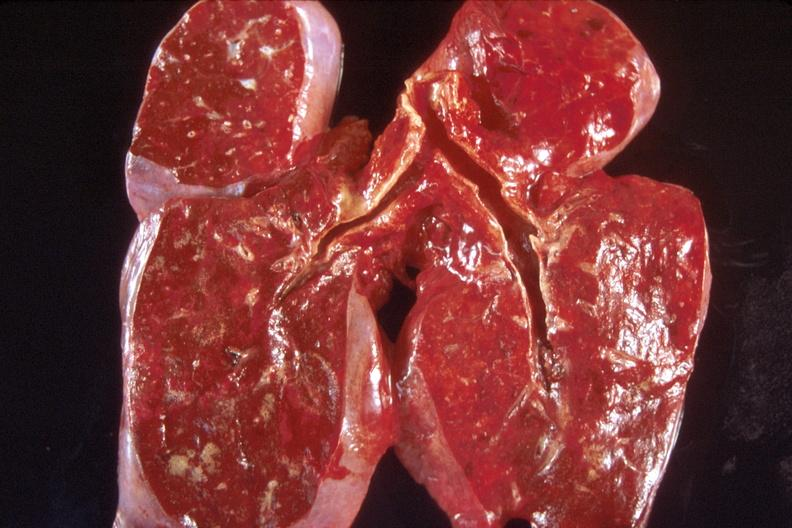s typical ivory vertebra present?
Answer the question using a single word or phrase. No 